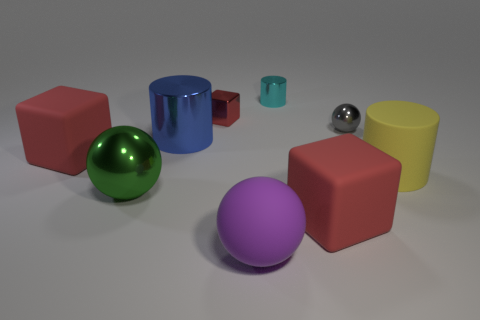Subtract all large yellow cylinders. How many cylinders are left? 2 Subtract 2 cubes. How many cubes are left? 1 Subtract all green spheres. How many spheres are left? 2 Subtract all purple balls. Subtract all green cylinders. How many balls are left? 2 Subtract all purple cubes. How many green balls are left? 1 Subtract all small cyan things. Subtract all tiny spheres. How many objects are left? 7 Add 4 large purple rubber objects. How many large purple rubber objects are left? 5 Add 6 gray spheres. How many gray spheres exist? 7 Subtract 0 brown cylinders. How many objects are left? 9 Subtract all cylinders. How many objects are left? 6 